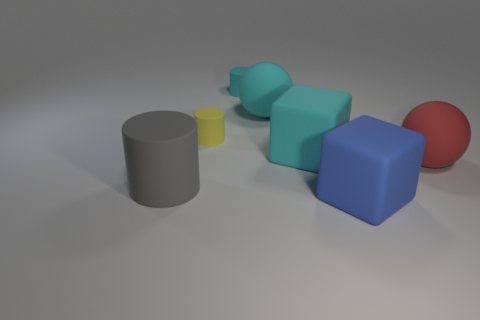Add 3 tiny green shiny objects. How many objects exist? 10 Subtract all cylinders. How many objects are left? 4 Add 4 yellow cylinders. How many yellow cylinders exist? 5 Subtract 0 yellow cubes. How many objects are left? 7 Subtract all tiny green matte cylinders. Subtract all cyan rubber spheres. How many objects are left? 6 Add 3 tiny yellow matte objects. How many tiny yellow matte objects are left? 4 